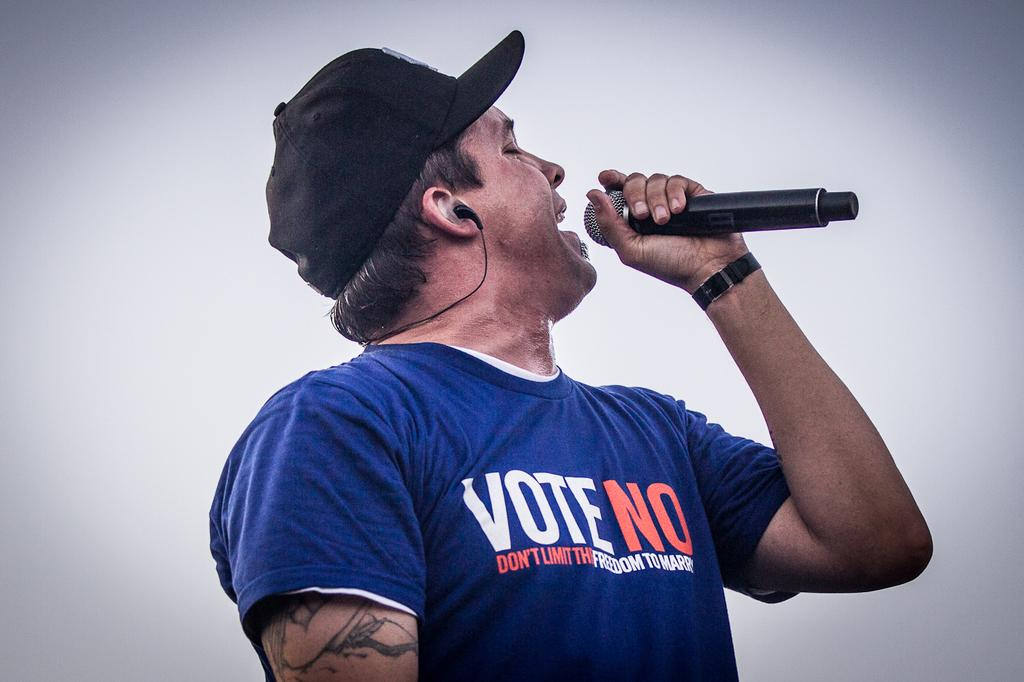What is the main subject of the image? There is a man in the middle of the image. What is the man wearing on his upper body? The man is wearing a t-shirt. What is the man wearing on his head? The man is wearing a cap. What is the man holding in his hand? The man is holding a microphone. What is the man doing in the image? The man is singing. What color is the background of the image? The background of the image is white. Can you see any fog in the image? There is no fog present in the image. Is there a division between the man and the background in the image? The image does not show any divisions between the man and the background; it appears to be a continuous scene. 